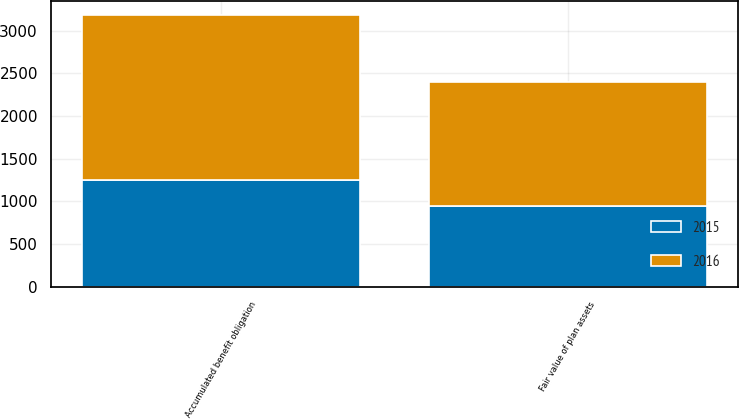Convert chart to OTSL. <chart><loc_0><loc_0><loc_500><loc_500><stacked_bar_chart><ecel><fcel>Accumulated benefit obligation<fcel>Fair value of plan assets<nl><fcel>2016<fcel>1933.2<fcel>1449.5<nl><fcel>2015<fcel>1249.9<fcel>948.4<nl></chart> 